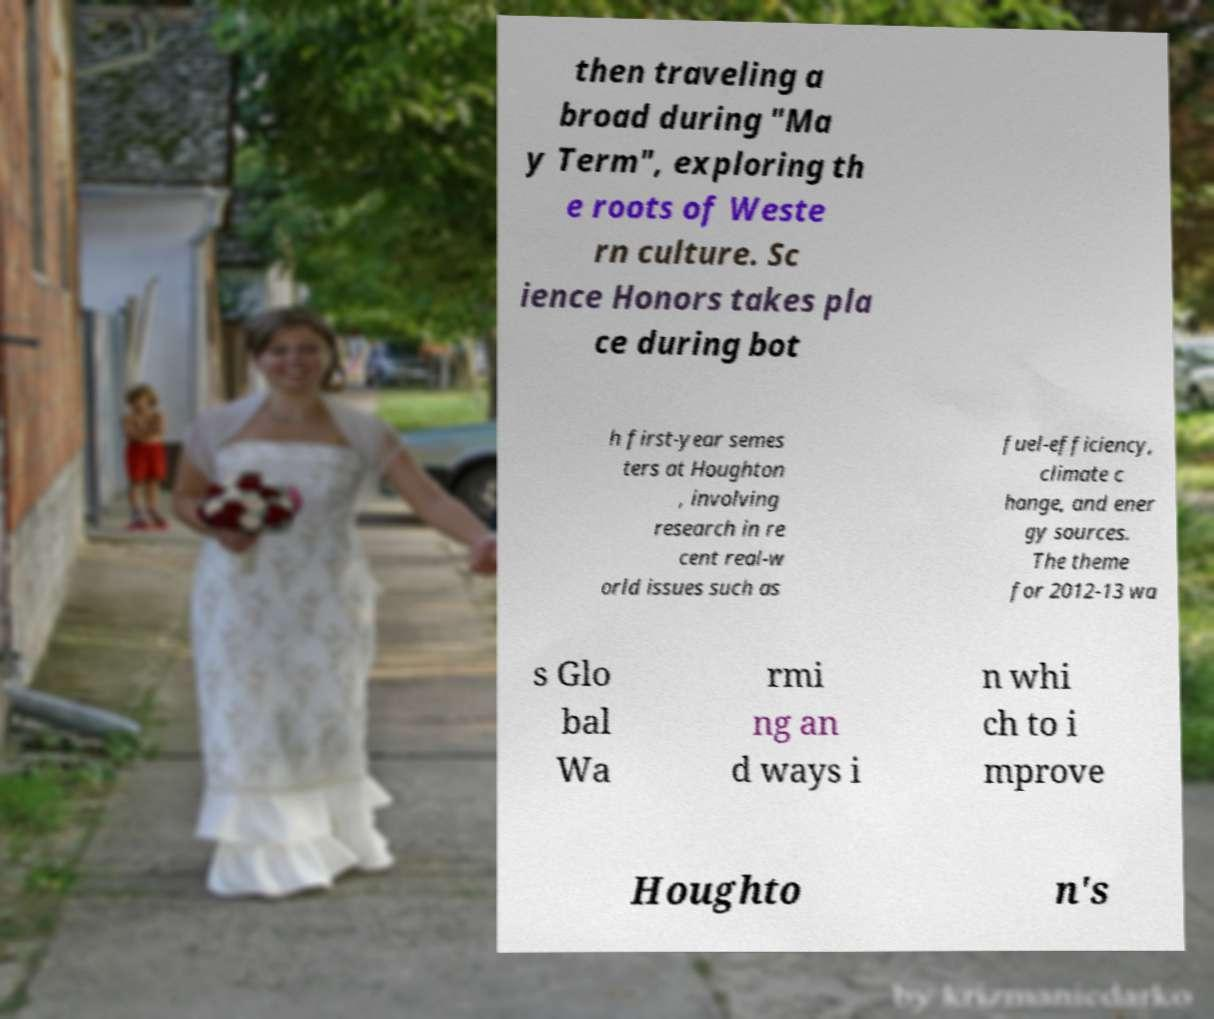Can you accurately transcribe the text from the provided image for me? then traveling a broad during "Ma y Term", exploring th e roots of Weste rn culture. Sc ience Honors takes pla ce during bot h first-year semes ters at Houghton , involving research in re cent real-w orld issues such as fuel-efficiency, climate c hange, and ener gy sources. The theme for 2012-13 wa s Glo bal Wa rmi ng an d ways i n whi ch to i mprove Houghto n's 